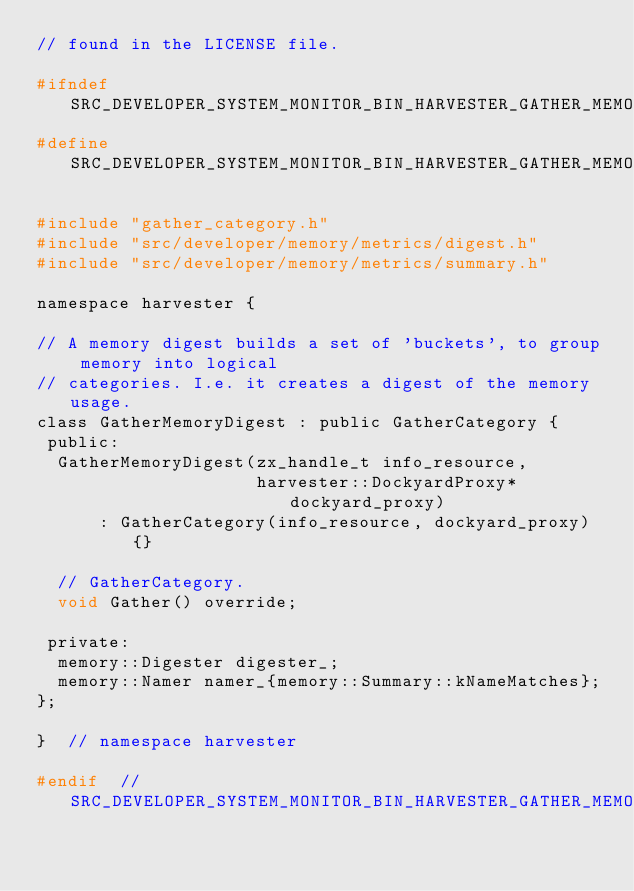<code> <loc_0><loc_0><loc_500><loc_500><_C_>// found in the LICENSE file.

#ifndef SRC_DEVELOPER_SYSTEM_MONITOR_BIN_HARVESTER_GATHER_MEMORY_DIGEST_H_
#define SRC_DEVELOPER_SYSTEM_MONITOR_BIN_HARVESTER_GATHER_MEMORY_DIGEST_H_

#include "gather_category.h"
#include "src/developer/memory/metrics/digest.h"
#include "src/developer/memory/metrics/summary.h"

namespace harvester {

// A memory digest builds a set of 'buckets', to group memory into logical
// categories. I.e. it creates a digest of the memory usage.
class GatherMemoryDigest : public GatherCategory {
 public:
  GatherMemoryDigest(zx_handle_t info_resource,
                     harvester::DockyardProxy* dockyard_proxy)
      : GatherCategory(info_resource, dockyard_proxy) {}

  // GatherCategory.
  void Gather() override;

 private:
  memory::Digester digester_;
  memory::Namer namer_{memory::Summary::kNameMatches};
};

}  // namespace harvester

#endif  // SRC_DEVELOPER_SYSTEM_MONITOR_BIN_HARVESTER_GATHER_MEMORY_DIGEST_H_
</code> 